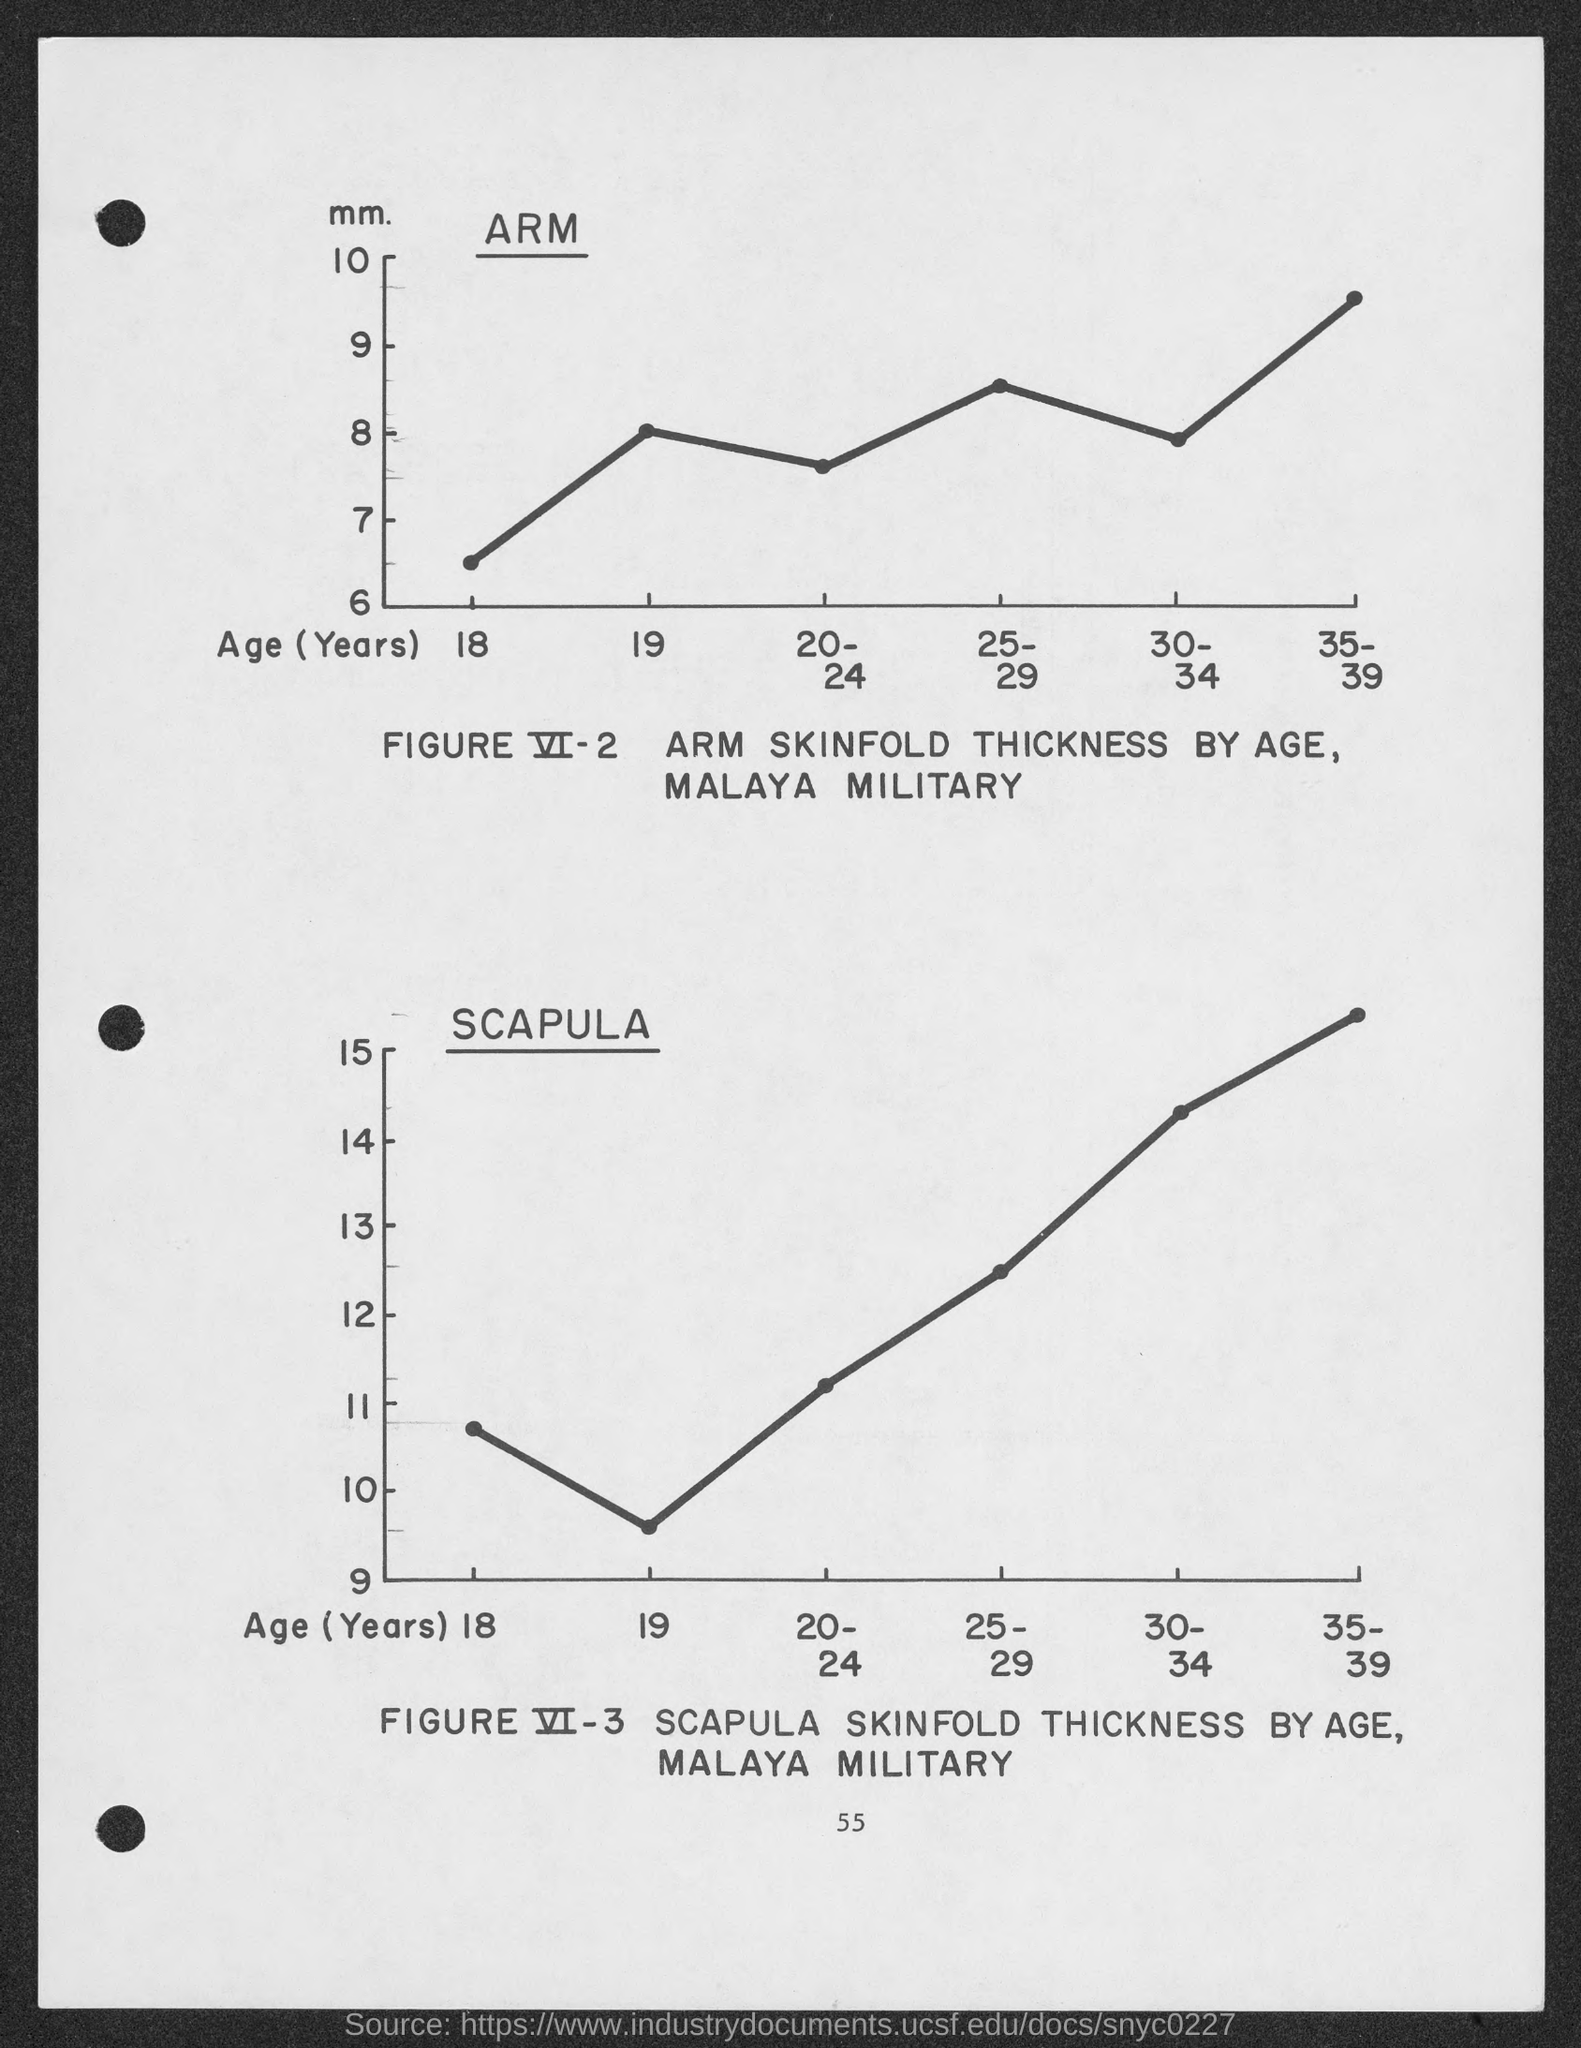What is the unit on Y axis of the graph in FIGURE VI-2?
Offer a very short reply. Mm. What is the variable on X axis of FIGURE VI-3?
Your answer should be compact. Age (Years). 